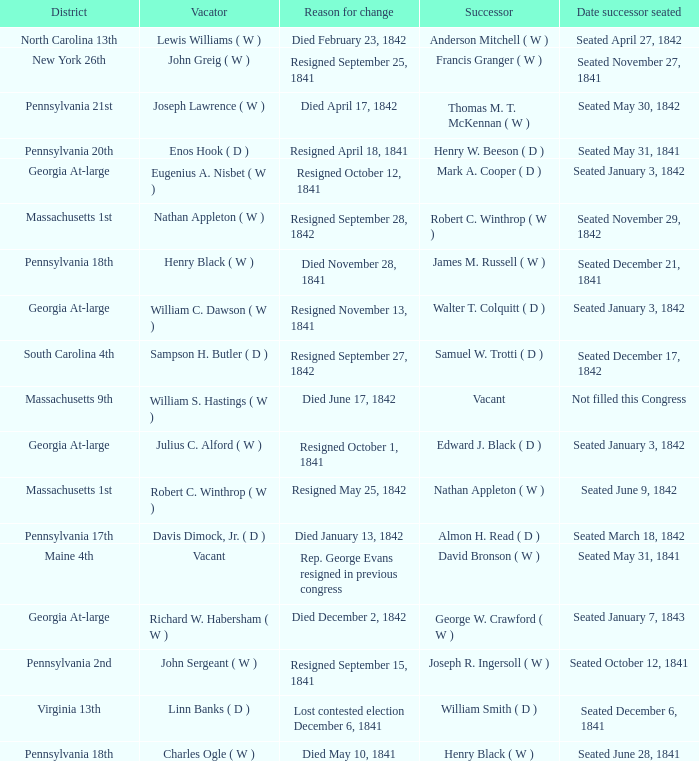Name the successor for north carolina 13th Anderson Mitchell ( W ). 